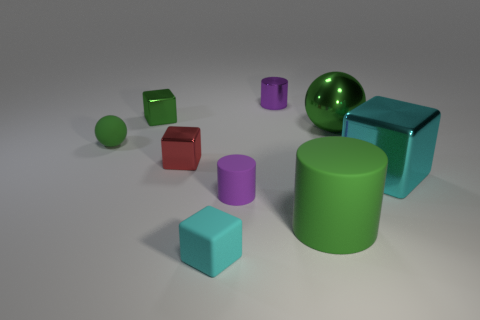Subtract all small cylinders. How many cylinders are left? 1 Subtract all red blocks. How many purple cylinders are left? 2 Add 1 big green metal spheres. How many objects exist? 10 Subtract 2 blocks. How many blocks are left? 2 Subtract all green cylinders. How many cylinders are left? 2 Subtract all spheres. How many objects are left? 7 Subtract all gray cylinders. Subtract all red blocks. How many cylinders are left? 3 Subtract all cyan cubes. Subtract all purple matte cylinders. How many objects are left? 6 Add 2 cyan things. How many cyan things are left? 4 Add 4 large cyan metal cylinders. How many large cyan metal cylinders exist? 4 